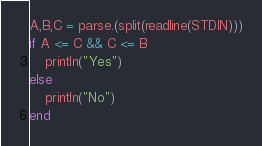<code> <loc_0><loc_0><loc_500><loc_500><_Julia_>A,B,C = parse.(split(readline(STDIN)))
if A <= C && C <= B
    println("Yes")
else
    println("No")
end</code> 